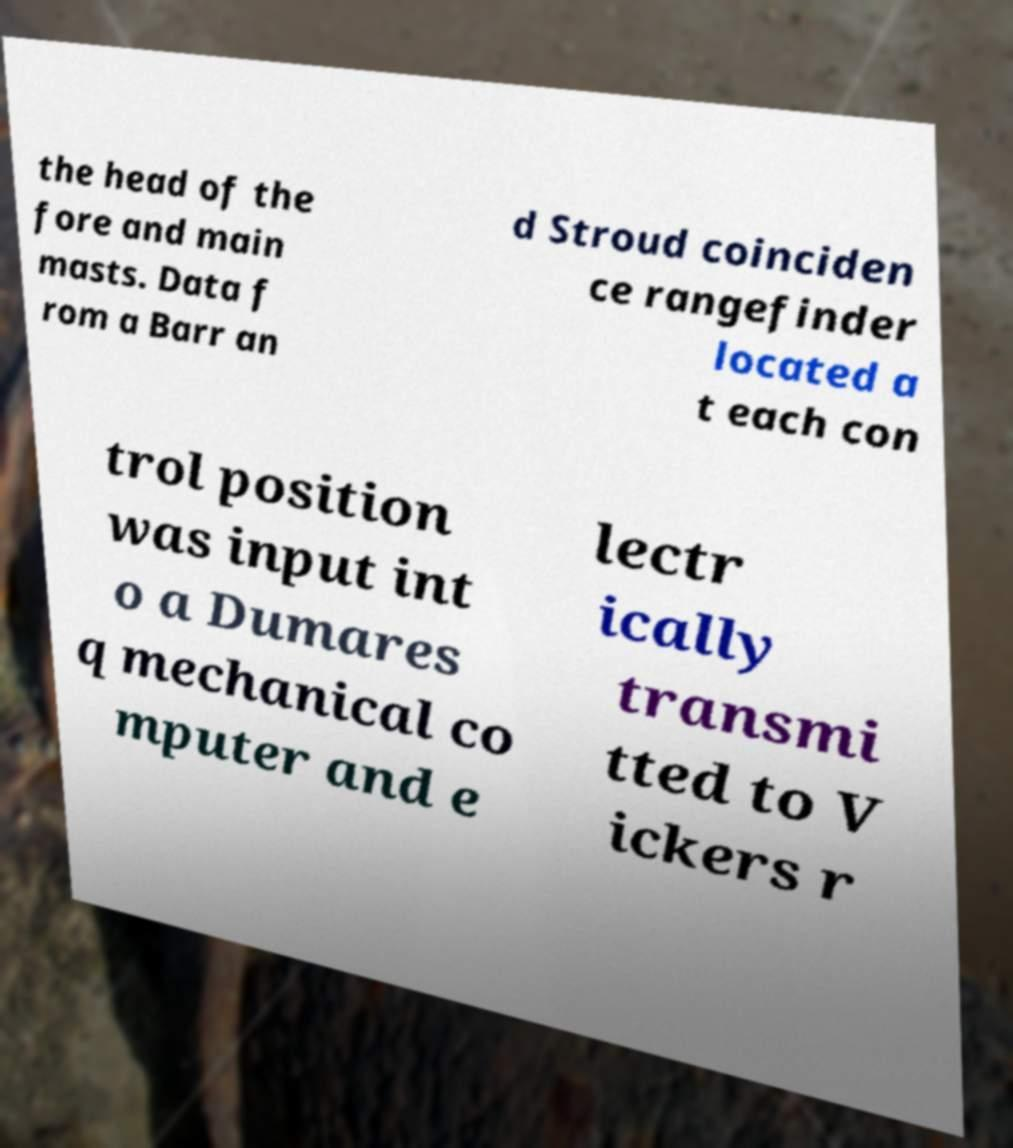Please read and relay the text visible in this image. What does it say? the head of the fore and main masts. Data f rom a Barr an d Stroud coinciden ce rangefinder located a t each con trol position was input int o a Dumares q mechanical co mputer and e lectr ically transmi tted to V ickers r 